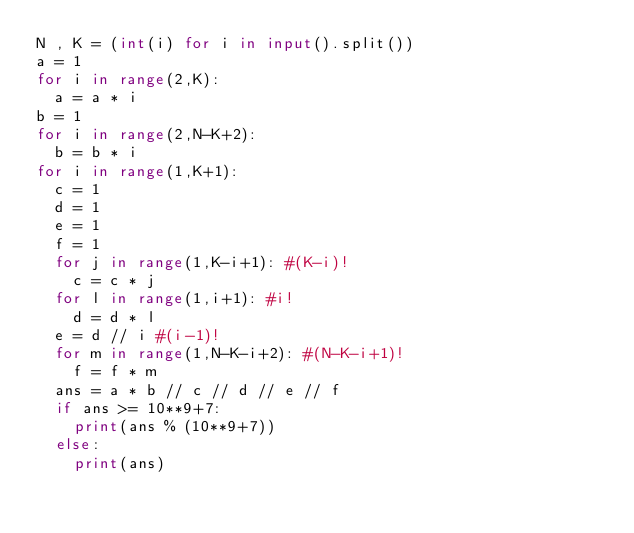<code> <loc_0><loc_0><loc_500><loc_500><_Python_>N , K = (int(i) for i in input().split())
a = 1
for i in range(2,K):
  a = a * i
b = 1
for i in range(2,N-K+2):
  b = b * i
for i in range(1,K+1):
  c = 1
  d = 1
  e = 1
  f = 1
  for j in range(1,K-i+1): #(K-i)!
    c = c * j 
  for l in range(1,i+1): #i!
    d = d * l
  e = d // i #(i-1)!
  for m in range(1,N-K-i+2): #(N-K-i+1)!
    f = f * m
  ans = a * b // c // d // e // f
  if ans >= 10**9+7:
    print(ans % (10**9+7))
  else:
    print(ans)</code> 